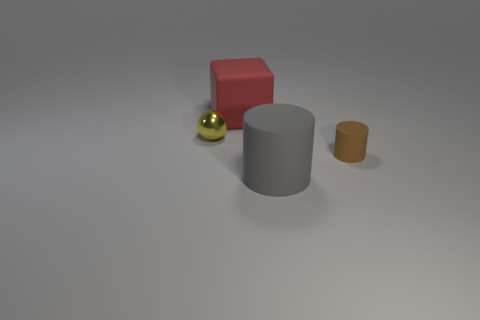What number of things are large yellow matte cylinders or matte things in front of the shiny object?
Provide a short and direct response. 2. What is the color of the matte object that is left of the brown matte cylinder and behind the gray object?
Provide a short and direct response. Red. Is the red object the same size as the gray matte object?
Keep it short and to the point. Yes. What color is the large object on the left side of the large gray cylinder?
Provide a short and direct response. Red. The matte thing that is the same size as the rubber block is what color?
Provide a succinct answer. Gray. Does the large red thing have the same shape as the small brown matte thing?
Give a very brief answer. No. What is the small object that is to the right of the red thing made of?
Your answer should be compact. Rubber. What is the color of the big rubber block?
Offer a terse response. Red. There is a red rubber cube that is on the right side of the tiny metal sphere; is its size the same as the cylinder on the left side of the brown matte cylinder?
Your answer should be very brief. Yes. There is a object that is both on the left side of the big gray matte cylinder and right of the metallic sphere; how big is it?
Keep it short and to the point. Large. 